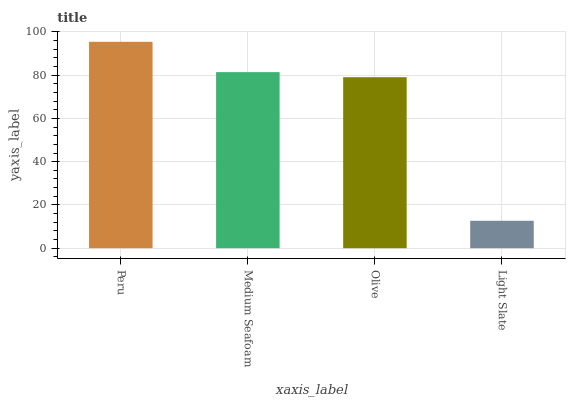Is Light Slate the minimum?
Answer yes or no. Yes. Is Peru the maximum?
Answer yes or no. Yes. Is Medium Seafoam the minimum?
Answer yes or no. No. Is Medium Seafoam the maximum?
Answer yes or no. No. Is Peru greater than Medium Seafoam?
Answer yes or no. Yes. Is Medium Seafoam less than Peru?
Answer yes or no. Yes. Is Medium Seafoam greater than Peru?
Answer yes or no. No. Is Peru less than Medium Seafoam?
Answer yes or no. No. Is Medium Seafoam the high median?
Answer yes or no. Yes. Is Olive the low median?
Answer yes or no. Yes. Is Light Slate the high median?
Answer yes or no. No. Is Light Slate the low median?
Answer yes or no. No. 